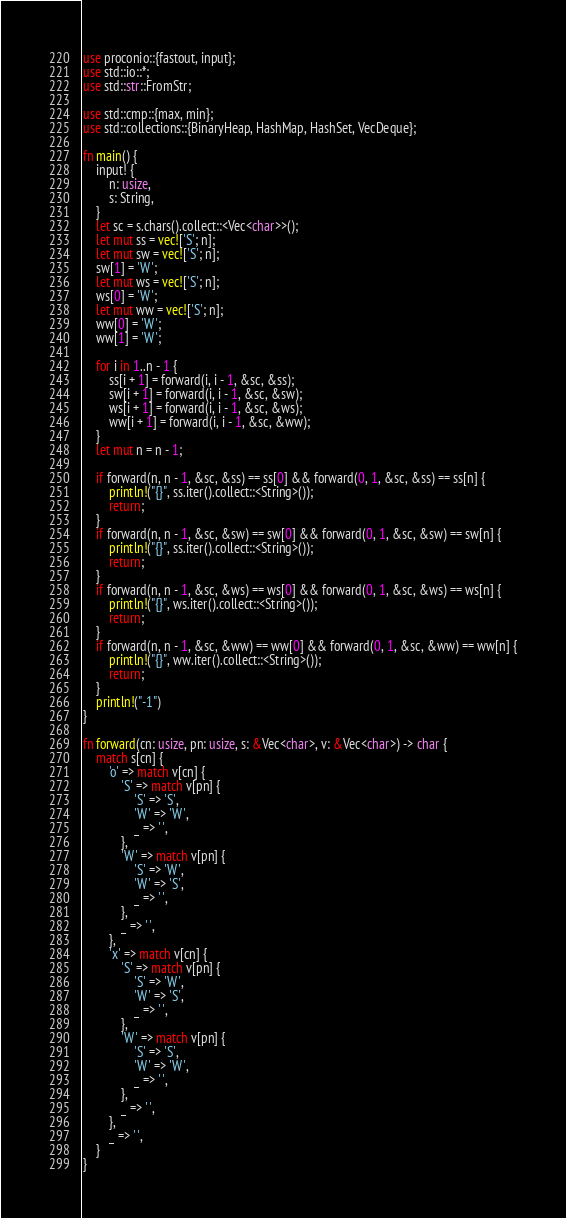Convert code to text. <code><loc_0><loc_0><loc_500><loc_500><_Rust_>use proconio::{fastout, input};
use std::io::*;
use std::str::FromStr;

use std::cmp::{max, min};
use std::collections::{BinaryHeap, HashMap, HashSet, VecDeque};

fn main() {
    input! {
        n: usize,
        s: String,
    }
    let sc = s.chars().collect::<Vec<char>>();
    let mut ss = vec!['S'; n];
    let mut sw = vec!['S'; n];
    sw[1] = 'W';
    let mut ws = vec!['S'; n];
    ws[0] = 'W';
    let mut ww = vec!['S'; n];
    ww[0] = 'W';
    ww[1] = 'W';

    for i in 1..n - 1 {
        ss[i + 1] = forward(i, i - 1, &sc, &ss);
        sw[i + 1] = forward(i, i - 1, &sc, &sw);
        ws[i + 1] = forward(i, i - 1, &sc, &ws);
        ww[i + 1] = forward(i, i - 1, &sc, &ww);
    }
    let mut n = n - 1;

    if forward(n, n - 1, &sc, &ss) == ss[0] && forward(0, 1, &sc, &ss) == ss[n] {
        println!("{}", ss.iter().collect::<String>());
        return;
    }
    if forward(n, n - 1, &sc, &sw) == sw[0] && forward(0, 1, &sc, &sw) == sw[n] {
        println!("{}", ss.iter().collect::<String>());
        return;
    }
    if forward(n, n - 1, &sc, &ws) == ws[0] && forward(0, 1, &sc, &ws) == ws[n] {
        println!("{}", ws.iter().collect::<String>());
        return;
    }
    if forward(n, n - 1, &sc, &ww) == ww[0] && forward(0, 1, &sc, &ww) == ww[n] {
        println!("{}", ww.iter().collect::<String>());
        return;
    }
    println!("-1")
}

fn forward(cn: usize, pn: usize, s: &Vec<char>, v: &Vec<char>) -> char {
    match s[cn] {
        'o' => match v[cn] {
            'S' => match v[pn] {
                'S' => 'S',
                'W' => 'W',
                _ => ' ',
            },
            'W' => match v[pn] {
                'S' => 'W',
                'W' => 'S',
                _ => ' ',
            },
            _ => ' ',
        },
        'x' => match v[cn] {
            'S' => match v[pn] {
                'S' => 'W',
                'W' => 'S',
                _ => ' ',
            },
            'W' => match v[pn] {
                'S' => 'S',
                'W' => 'W',
                _ => ' ',
            },
            _ => ' ',
        },
        _ => ' ',
    }
}
</code> 